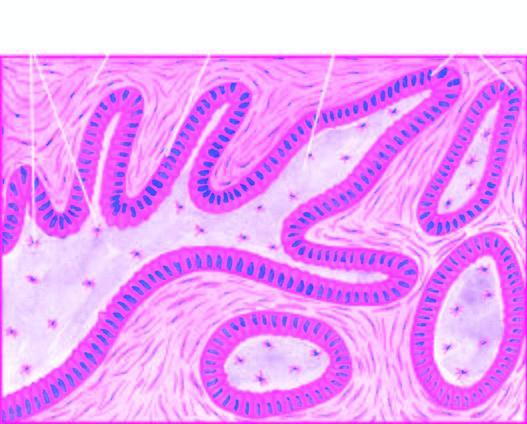do a few areas show central cystic change?
Answer the question using a single word or phrase. Yes 